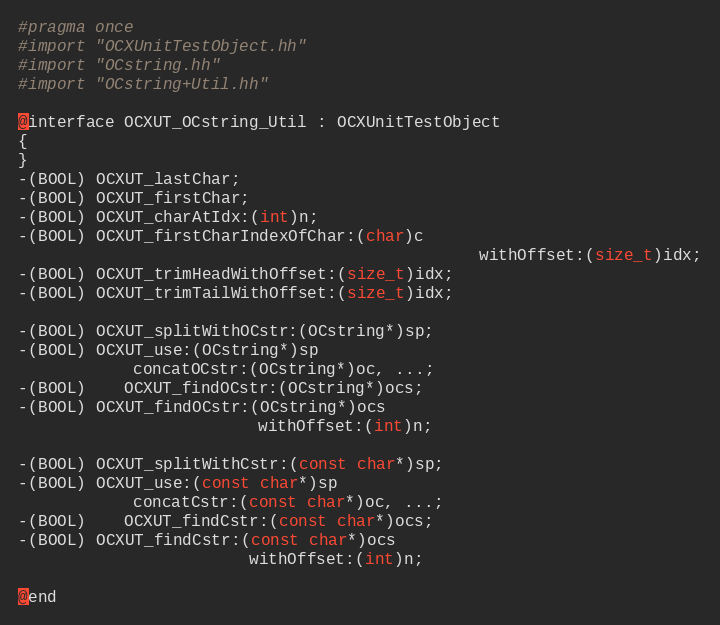<code> <loc_0><loc_0><loc_500><loc_500><_C++_>#pragma once 
#import "OCXUnitTestObject.hh"
#import "OCstring.hh"
#import "OCstring+Util.hh"

@interface OCXUT_OCstring_Util : OCXUnitTestObject
{
}
-(BOOL) OCXUT_lastChar;
-(BOOL) OCXUT_firstChar;
-(BOOL) OCXUT_charAtIdx:(int)n;
-(BOOL) OCXUT_firstCharIndexOfChar:(char)c
												withOffset:(size_t)idx;
-(BOOL) OCXUT_trimHeadWithOffset:(size_t)idx;
-(BOOL) OCXUT_trimTailWithOffset:(size_t)idx;

-(BOOL) OCXUT_splitWithOCstr:(OCstring*)sp;
-(BOOL) OCXUT_use:(OCstring*)sp
			concatOCstr:(OCstring*)oc, ...;
-(BOOL)	OCXUT_findOCstr:(OCstring*)ocs;
-(BOOL) OCXUT_findOCstr:(OCstring*)ocs
						 withOffset:(int)n;

-(BOOL) OCXUT_splitWithCstr:(const char*)sp;
-(BOOL) OCXUT_use:(const char*)sp
			concatCstr:(const char*)oc, ...;
-(BOOL)	OCXUT_findCstr:(const char*)ocs;
-(BOOL) OCXUT_findCstr:(const char*)ocs
						withOffset:(int)n;

@end
</code> 